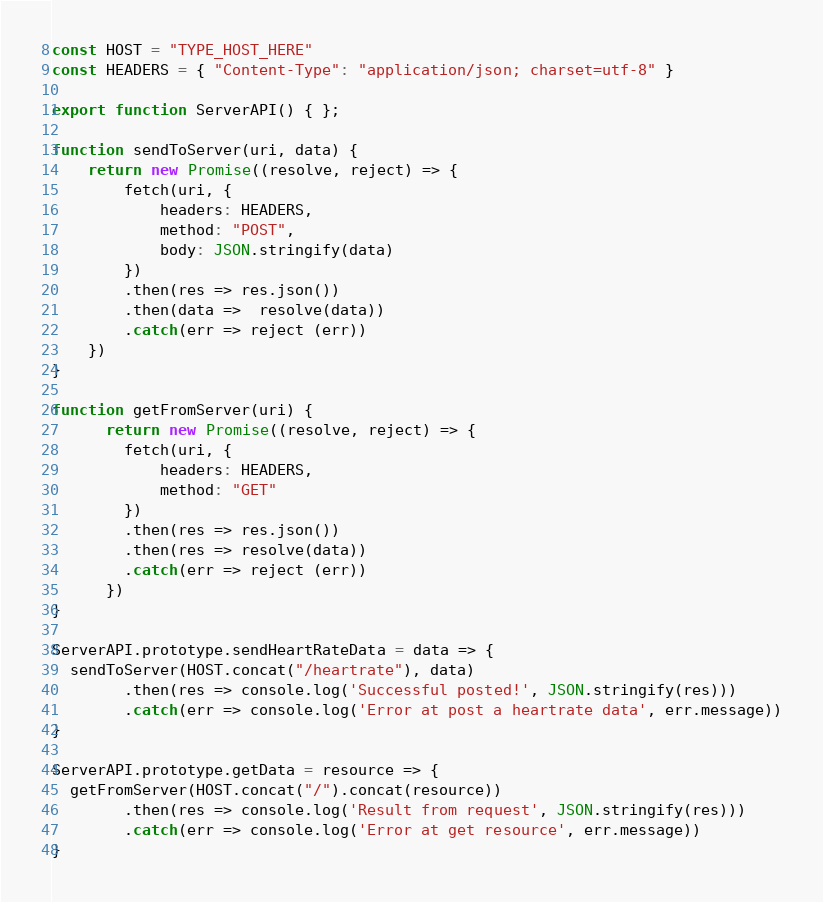Convert code to text. <code><loc_0><loc_0><loc_500><loc_500><_JavaScript_>const HOST = "TYPE_HOST_HERE"
const HEADERS = { "Content-Type": "application/json; charset=utf-8" }

export function ServerAPI() { };

function sendToServer(uri, data) {
    return new Promise((resolve, reject) => {
        fetch(uri, {
            headers: HEADERS,
            method: "POST",
            body: JSON.stringify(data)
        })
        .then(res => res.json())
        .then(data =>  resolve(data))
        .catch(err => reject (err))
    })
}

function getFromServer(uri) {
      return new Promise((resolve, reject) => {
        fetch(uri, {
            headers: HEADERS,
            method: "GET"
        })
        .then(res => res.json())
        .then(res => resolve(data))
        .catch(err => reject (err))
      })
}

ServerAPI.prototype.sendHeartRateData = data => {
  sendToServer(HOST.concat("/heartrate"), data)
        .then(res => console.log('Successful posted!', JSON.stringify(res)))
        .catch(err => console.log('Error at post a heartrate data', err.message))
}

ServerAPI.prototype.getData = resource => {
  getFromServer(HOST.concat("/").concat(resource))
        .then(res => console.log('Result from request', JSON.stringify(res)))
        .catch(err => console.log('Error at get resource', err.message))
}</code> 